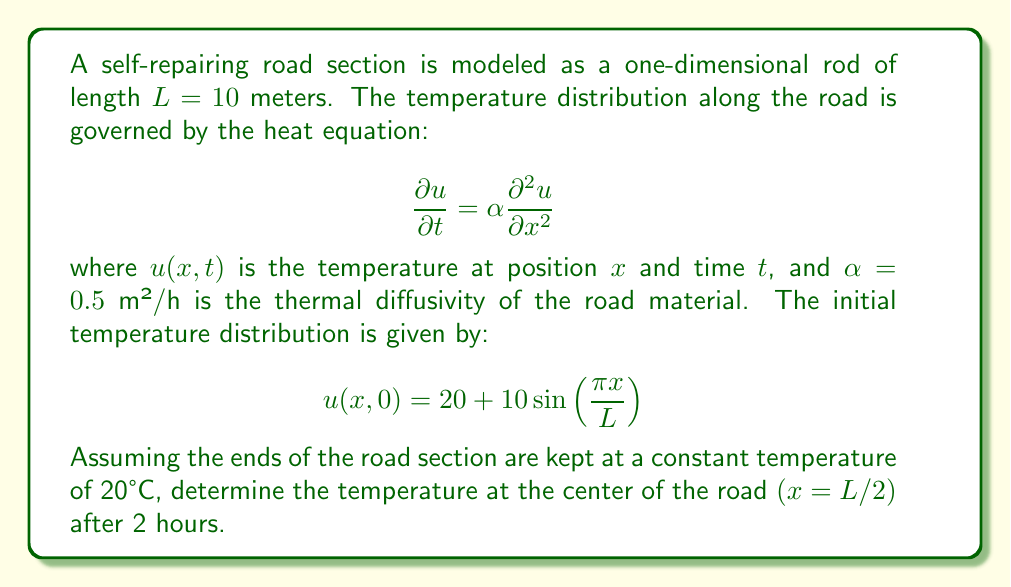Could you help me with this problem? To solve this problem, we'll follow these steps:

1) The heat equation with the given boundary conditions forms a boundary value problem. The solution can be expressed as a Fourier series:

   $$u(x,t) = 20 + \sum_{n=1}^{\infty} B_n \sin(\frac{n\pi x}{L}) e^{-\alpha (\frac{n\pi}{L})^2 t}$$

2) The initial condition is:

   $$u(x,0) = 20 + 10 \sin(\frac{\pi x}{L})$$

3) Comparing this with the general solution, we can see that only the first term of the series $(n=1)$ is non-zero, with $B_1 = 10$.

4) Therefore, the solution simplifies to:

   $$u(x,t) = 20 + 10 \sin(\frac{\pi x}{L}) e^{-\alpha (\frac{\pi}{L})^2 t}$$

5) We need to find $u(L/2, 2)$. Substituting the values:

   $$u(5, 2) = 20 + 10 \sin(\frac{\pi \cdot 5}{10}) e^{-0.5 (\frac{\pi}{10})^2 \cdot 2}$$

6) Simplify:

   $$u(5, 2) = 20 + 10 \sin(\frac{\pi}{2}) e^{-0.5 (\frac{\pi}{10})^2 \cdot 2}$$

7) $\sin(\frac{\pi}{2}) = 1$, so:

   $$u(5, 2) = 20 + 10 e^{-0.5 (\frac{\pi}{10})^2 \cdot 2}$$

8) Calculate the exponent: $-0.5 (\frac{\pi}{10})^2 \cdot 2 \approx -0.1974$

9) Therefore:

   $$u(5, 2) = 20 + 10 e^{-0.1974} \approx 20 + 10 \cdot 0.8209 \approx 28.209$$
Answer: 28.21°C 